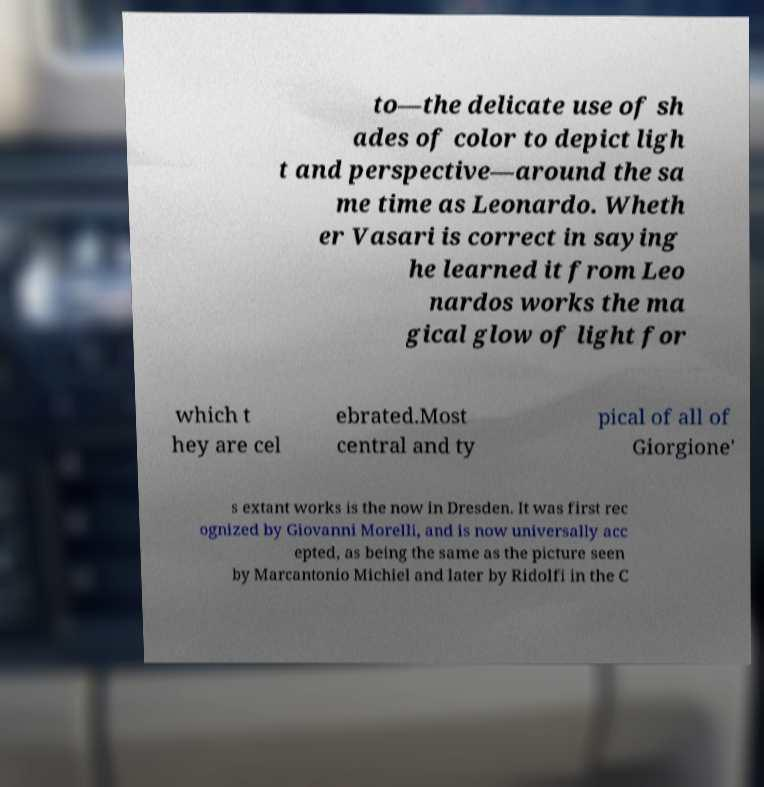Please read and relay the text visible in this image. What does it say? to—the delicate use of sh ades of color to depict ligh t and perspective—around the sa me time as Leonardo. Wheth er Vasari is correct in saying he learned it from Leo nardos works the ma gical glow of light for which t hey are cel ebrated.Most central and ty pical of all of Giorgione' s extant works is the now in Dresden. It was first rec ognized by Giovanni Morelli, and is now universally acc epted, as being the same as the picture seen by Marcantonio Michiel and later by Ridolfi in the C 